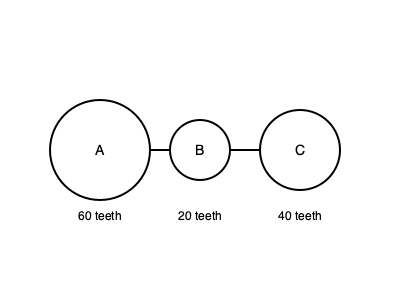In the gear train shown above, gear A rotates clockwise at 30 RPM. Determine the speed and direction of rotation of gear C. To solve this problem, we'll follow these steps:

1. Identify the gear ratios:
   - Gear A to B: $\frac{60}{20} = 3:1$
   - Gear B to C: $\frac{20}{40} = 1:2$

2. Calculate the speed of gear B:
   - Speed of B = Speed of A × (Teeth of A / Teeth of B)
   - Speed of B = 30 RPM × (60/20) = 90 RPM

3. Determine the direction of gear B:
   - Since A rotates clockwise, B will rotate counterclockwise

4. Calculate the speed of gear C:
   - Speed of C = Speed of B × (Teeth of B / Teeth of C)
   - Speed of C = 90 RPM × (20/40) = 45 RPM

5. Determine the direction of gear C:
   - Since B rotates counterclockwise, C will rotate clockwise

Therefore, gear C rotates clockwise at 45 RPM.
Answer: 45 RPM clockwise 